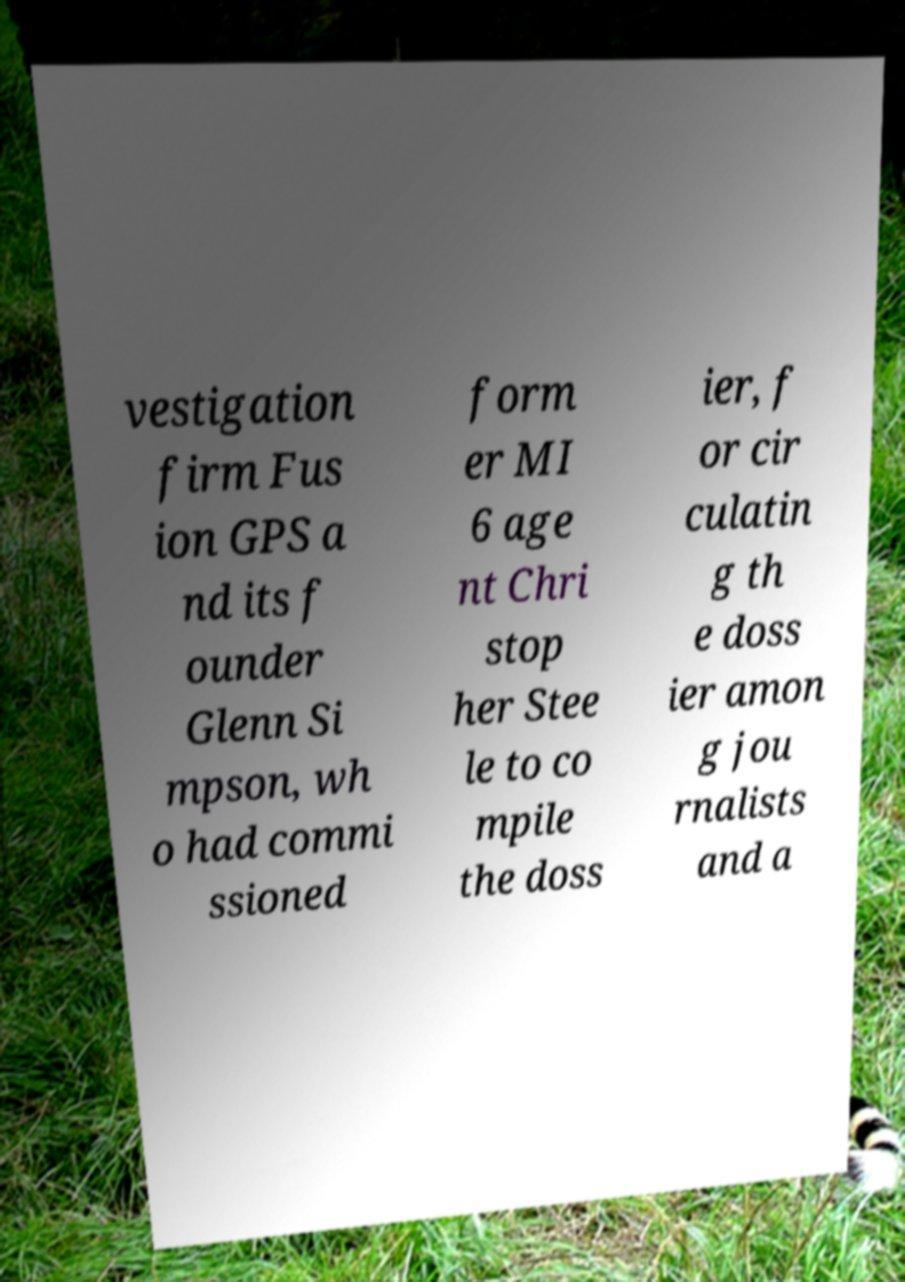Can you read and provide the text displayed in the image?This photo seems to have some interesting text. Can you extract and type it out for me? vestigation firm Fus ion GPS a nd its f ounder Glenn Si mpson, wh o had commi ssioned form er MI 6 age nt Chri stop her Stee le to co mpile the doss ier, f or cir culatin g th e doss ier amon g jou rnalists and a 